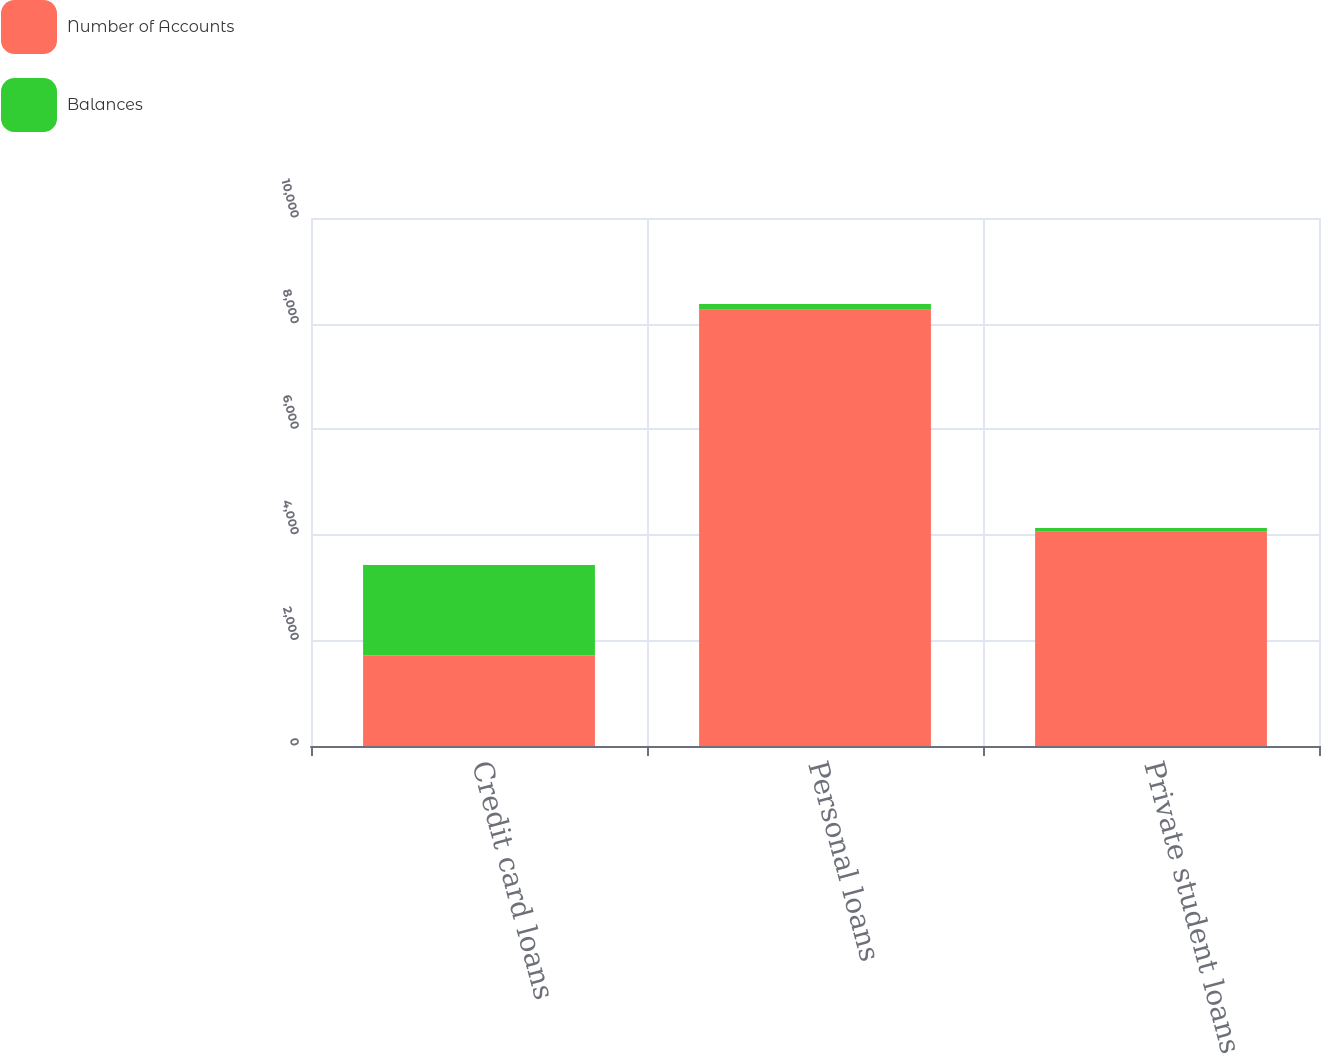<chart> <loc_0><loc_0><loc_500><loc_500><stacked_bar_chart><ecel><fcel>Credit card loans<fcel>Personal loans<fcel>Private student loans<nl><fcel>Number of Accounts<fcel>1713<fcel>8260<fcel>4057<nl><fcel>Balances<fcel>1713<fcel>111<fcel>74<nl></chart> 